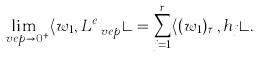Convert formula to latex. <formula><loc_0><loc_0><loc_500><loc_500>\lim _ { \ v e p \rightarrow 0 ^ { + } } \langle w _ { 1 } , L ^ { e } _ { \ v e p } \rangle = \sum _ { j = 1 } ^ { r } \langle ( w _ { 1 } ) _ { \tau _ { j } } , h _ { j } \rangle .</formula> 